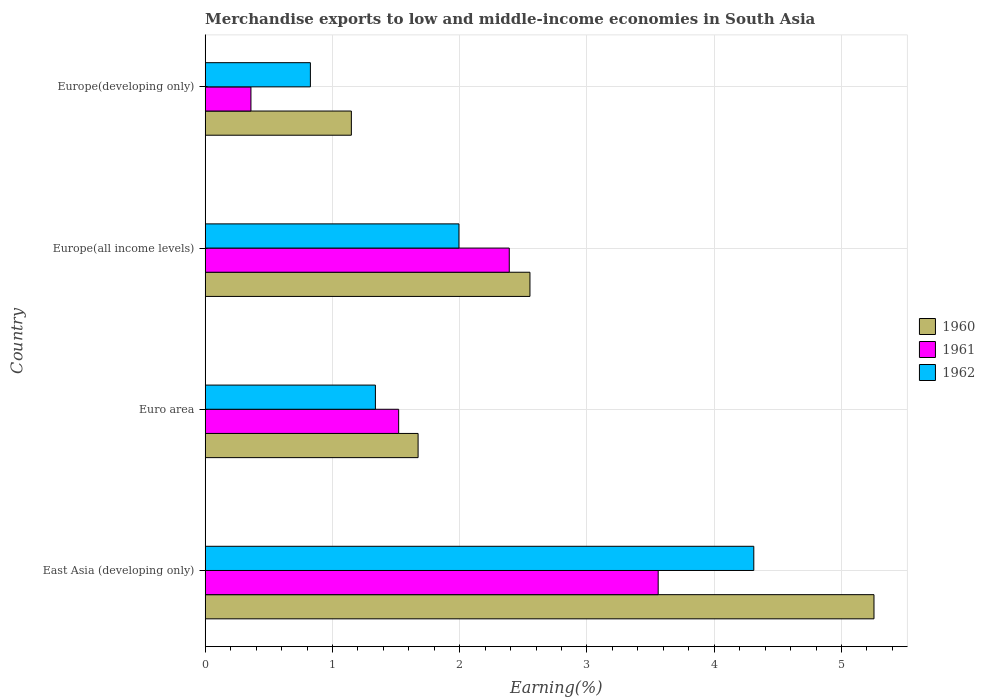How many different coloured bars are there?
Your answer should be compact. 3. How many groups of bars are there?
Your answer should be compact. 4. Are the number of bars on each tick of the Y-axis equal?
Provide a succinct answer. Yes. How many bars are there on the 2nd tick from the top?
Your answer should be very brief. 3. How many bars are there on the 2nd tick from the bottom?
Give a very brief answer. 3. What is the label of the 4th group of bars from the top?
Keep it short and to the point. East Asia (developing only). What is the percentage of amount earned from merchandise exports in 1961 in Europe(all income levels)?
Keep it short and to the point. 2.39. Across all countries, what is the maximum percentage of amount earned from merchandise exports in 1960?
Your response must be concise. 5.26. Across all countries, what is the minimum percentage of amount earned from merchandise exports in 1961?
Keep it short and to the point. 0.36. In which country was the percentage of amount earned from merchandise exports in 1961 maximum?
Offer a very short reply. East Asia (developing only). In which country was the percentage of amount earned from merchandise exports in 1962 minimum?
Your response must be concise. Europe(developing only). What is the total percentage of amount earned from merchandise exports in 1962 in the graph?
Offer a terse response. 8.47. What is the difference between the percentage of amount earned from merchandise exports in 1962 in East Asia (developing only) and that in Euro area?
Offer a terse response. 2.97. What is the difference between the percentage of amount earned from merchandise exports in 1960 in Europe(all income levels) and the percentage of amount earned from merchandise exports in 1961 in East Asia (developing only)?
Your answer should be very brief. -1.01. What is the average percentage of amount earned from merchandise exports in 1960 per country?
Your answer should be very brief. 2.66. What is the difference between the percentage of amount earned from merchandise exports in 1961 and percentage of amount earned from merchandise exports in 1960 in Euro area?
Offer a very short reply. -0.15. In how many countries, is the percentage of amount earned from merchandise exports in 1962 greater than 2.6 %?
Provide a short and direct response. 1. What is the ratio of the percentage of amount earned from merchandise exports in 1960 in East Asia (developing only) to that in Europe(developing only)?
Provide a short and direct response. 4.58. What is the difference between the highest and the second highest percentage of amount earned from merchandise exports in 1962?
Offer a terse response. 2.32. What is the difference between the highest and the lowest percentage of amount earned from merchandise exports in 1962?
Give a very brief answer. 3.48. In how many countries, is the percentage of amount earned from merchandise exports in 1962 greater than the average percentage of amount earned from merchandise exports in 1962 taken over all countries?
Offer a very short reply. 1. What does the 1st bar from the top in Euro area represents?
Your response must be concise. 1962. What does the 1st bar from the bottom in East Asia (developing only) represents?
Provide a succinct answer. 1960. Is it the case that in every country, the sum of the percentage of amount earned from merchandise exports in 1962 and percentage of amount earned from merchandise exports in 1961 is greater than the percentage of amount earned from merchandise exports in 1960?
Offer a very short reply. Yes. How many bars are there?
Provide a short and direct response. 12. Where does the legend appear in the graph?
Give a very brief answer. Center right. How many legend labels are there?
Provide a short and direct response. 3. What is the title of the graph?
Offer a very short reply. Merchandise exports to low and middle-income economies in South Asia. Does "1971" appear as one of the legend labels in the graph?
Make the answer very short. No. What is the label or title of the X-axis?
Ensure brevity in your answer.  Earning(%). What is the Earning(%) of 1960 in East Asia (developing only)?
Make the answer very short. 5.26. What is the Earning(%) of 1961 in East Asia (developing only)?
Ensure brevity in your answer.  3.56. What is the Earning(%) in 1962 in East Asia (developing only)?
Your response must be concise. 4.31. What is the Earning(%) in 1960 in Euro area?
Provide a short and direct response. 1.67. What is the Earning(%) in 1961 in Euro area?
Give a very brief answer. 1.52. What is the Earning(%) in 1962 in Euro area?
Your response must be concise. 1.34. What is the Earning(%) of 1960 in Europe(all income levels)?
Make the answer very short. 2.55. What is the Earning(%) in 1961 in Europe(all income levels)?
Your answer should be very brief. 2.39. What is the Earning(%) in 1962 in Europe(all income levels)?
Ensure brevity in your answer.  1.99. What is the Earning(%) of 1960 in Europe(developing only)?
Make the answer very short. 1.15. What is the Earning(%) of 1961 in Europe(developing only)?
Your response must be concise. 0.36. What is the Earning(%) in 1962 in Europe(developing only)?
Your answer should be compact. 0.83. Across all countries, what is the maximum Earning(%) of 1960?
Provide a short and direct response. 5.26. Across all countries, what is the maximum Earning(%) in 1961?
Provide a short and direct response. 3.56. Across all countries, what is the maximum Earning(%) in 1962?
Ensure brevity in your answer.  4.31. Across all countries, what is the minimum Earning(%) in 1960?
Your answer should be very brief. 1.15. Across all countries, what is the minimum Earning(%) of 1961?
Ensure brevity in your answer.  0.36. Across all countries, what is the minimum Earning(%) of 1962?
Provide a short and direct response. 0.83. What is the total Earning(%) of 1960 in the graph?
Offer a very short reply. 10.63. What is the total Earning(%) in 1961 in the graph?
Your response must be concise. 7.83. What is the total Earning(%) in 1962 in the graph?
Make the answer very short. 8.47. What is the difference between the Earning(%) of 1960 in East Asia (developing only) and that in Euro area?
Your answer should be compact. 3.58. What is the difference between the Earning(%) in 1961 in East Asia (developing only) and that in Euro area?
Provide a succinct answer. 2.04. What is the difference between the Earning(%) in 1962 in East Asia (developing only) and that in Euro area?
Your answer should be very brief. 2.97. What is the difference between the Earning(%) of 1960 in East Asia (developing only) and that in Europe(all income levels)?
Give a very brief answer. 2.7. What is the difference between the Earning(%) of 1961 in East Asia (developing only) and that in Europe(all income levels)?
Give a very brief answer. 1.17. What is the difference between the Earning(%) of 1962 in East Asia (developing only) and that in Europe(all income levels)?
Provide a short and direct response. 2.32. What is the difference between the Earning(%) of 1960 in East Asia (developing only) and that in Europe(developing only)?
Provide a succinct answer. 4.11. What is the difference between the Earning(%) in 1961 in East Asia (developing only) and that in Europe(developing only)?
Your response must be concise. 3.2. What is the difference between the Earning(%) in 1962 in East Asia (developing only) and that in Europe(developing only)?
Your response must be concise. 3.48. What is the difference between the Earning(%) of 1960 in Euro area and that in Europe(all income levels)?
Provide a succinct answer. -0.88. What is the difference between the Earning(%) of 1961 in Euro area and that in Europe(all income levels)?
Provide a succinct answer. -0.87. What is the difference between the Earning(%) of 1962 in Euro area and that in Europe(all income levels)?
Provide a short and direct response. -0.66. What is the difference between the Earning(%) in 1960 in Euro area and that in Europe(developing only)?
Your answer should be very brief. 0.52. What is the difference between the Earning(%) in 1961 in Euro area and that in Europe(developing only)?
Your response must be concise. 1.16. What is the difference between the Earning(%) in 1962 in Euro area and that in Europe(developing only)?
Offer a terse response. 0.51. What is the difference between the Earning(%) in 1960 in Europe(all income levels) and that in Europe(developing only)?
Ensure brevity in your answer.  1.4. What is the difference between the Earning(%) in 1961 in Europe(all income levels) and that in Europe(developing only)?
Provide a short and direct response. 2.03. What is the difference between the Earning(%) in 1962 in Europe(all income levels) and that in Europe(developing only)?
Your response must be concise. 1.17. What is the difference between the Earning(%) of 1960 in East Asia (developing only) and the Earning(%) of 1961 in Euro area?
Your response must be concise. 3.74. What is the difference between the Earning(%) in 1960 in East Asia (developing only) and the Earning(%) in 1962 in Euro area?
Give a very brief answer. 3.92. What is the difference between the Earning(%) in 1961 in East Asia (developing only) and the Earning(%) in 1962 in Euro area?
Your response must be concise. 2.22. What is the difference between the Earning(%) of 1960 in East Asia (developing only) and the Earning(%) of 1961 in Europe(all income levels)?
Make the answer very short. 2.87. What is the difference between the Earning(%) of 1960 in East Asia (developing only) and the Earning(%) of 1962 in Europe(all income levels)?
Give a very brief answer. 3.26. What is the difference between the Earning(%) in 1961 in East Asia (developing only) and the Earning(%) in 1962 in Europe(all income levels)?
Provide a short and direct response. 1.57. What is the difference between the Earning(%) of 1960 in East Asia (developing only) and the Earning(%) of 1961 in Europe(developing only)?
Your response must be concise. 4.9. What is the difference between the Earning(%) of 1960 in East Asia (developing only) and the Earning(%) of 1962 in Europe(developing only)?
Keep it short and to the point. 4.43. What is the difference between the Earning(%) of 1961 in East Asia (developing only) and the Earning(%) of 1962 in Europe(developing only)?
Give a very brief answer. 2.73. What is the difference between the Earning(%) of 1960 in Euro area and the Earning(%) of 1961 in Europe(all income levels)?
Offer a terse response. -0.72. What is the difference between the Earning(%) of 1960 in Euro area and the Earning(%) of 1962 in Europe(all income levels)?
Offer a terse response. -0.32. What is the difference between the Earning(%) in 1961 in Euro area and the Earning(%) in 1962 in Europe(all income levels)?
Give a very brief answer. -0.47. What is the difference between the Earning(%) of 1960 in Euro area and the Earning(%) of 1961 in Europe(developing only)?
Ensure brevity in your answer.  1.31. What is the difference between the Earning(%) of 1960 in Euro area and the Earning(%) of 1962 in Europe(developing only)?
Ensure brevity in your answer.  0.85. What is the difference between the Earning(%) in 1961 in Euro area and the Earning(%) in 1962 in Europe(developing only)?
Provide a short and direct response. 0.69. What is the difference between the Earning(%) in 1960 in Europe(all income levels) and the Earning(%) in 1961 in Europe(developing only)?
Provide a short and direct response. 2.19. What is the difference between the Earning(%) of 1960 in Europe(all income levels) and the Earning(%) of 1962 in Europe(developing only)?
Your response must be concise. 1.73. What is the difference between the Earning(%) in 1961 in Europe(all income levels) and the Earning(%) in 1962 in Europe(developing only)?
Provide a short and direct response. 1.56. What is the average Earning(%) in 1960 per country?
Provide a succinct answer. 2.66. What is the average Earning(%) in 1961 per country?
Keep it short and to the point. 1.96. What is the average Earning(%) of 1962 per country?
Ensure brevity in your answer.  2.12. What is the difference between the Earning(%) of 1960 and Earning(%) of 1961 in East Asia (developing only)?
Your answer should be very brief. 1.7. What is the difference between the Earning(%) in 1960 and Earning(%) in 1962 in East Asia (developing only)?
Offer a very short reply. 0.94. What is the difference between the Earning(%) in 1961 and Earning(%) in 1962 in East Asia (developing only)?
Offer a terse response. -0.75. What is the difference between the Earning(%) in 1960 and Earning(%) in 1961 in Euro area?
Offer a terse response. 0.15. What is the difference between the Earning(%) in 1960 and Earning(%) in 1962 in Euro area?
Your response must be concise. 0.34. What is the difference between the Earning(%) in 1961 and Earning(%) in 1962 in Euro area?
Provide a succinct answer. 0.18. What is the difference between the Earning(%) in 1960 and Earning(%) in 1961 in Europe(all income levels)?
Give a very brief answer. 0.16. What is the difference between the Earning(%) in 1960 and Earning(%) in 1962 in Europe(all income levels)?
Your answer should be very brief. 0.56. What is the difference between the Earning(%) in 1961 and Earning(%) in 1962 in Europe(all income levels)?
Your answer should be very brief. 0.4. What is the difference between the Earning(%) in 1960 and Earning(%) in 1961 in Europe(developing only)?
Provide a short and direct response. 0.79. What is the difference between the Earning(%) of 1960 and Earning(%) of 1962 in Europe(developing only)?
Offer a terse response. 0.32. What is the difference between the Earning(%) in 1961 and Earning(%) in 1962 in Europe(developing only)?
Offer a terse response. -0.47. What is the ratio of the Earning(%) of 1960 in East Asia (developing only) to that in Euro area?
Keep it short and to the point. 3.14. What is the ratio of the Earning(%) in 1961 in East Asia (developing only) to that in Euro area?
Keep it short and to the point. 2.34. What is the ratio of the Earning(%) of 1962 in East Asia (developing only) to that in Euro area?
Provide a succinct answer. 3.22. What is the ratio of the Earning(%) in 1960 in East Asia (developing only) to that in Europe(all income levels)?
Your answer should be very brief. 2.06. What is the ratio of the Earning(%) in 1961 in East Asia (developing only) to that in Europe(all income levels)?
Offer a very short reply. 1.49. What is the ratio of the Earning(%) of 1962 in East Asia (developing only) to that in Europe(all income levels)?
Offer a terse response. 2.16. What is the ratio of the Earning(%) of 1960 in East Asia (developing only) to that in Europe(developing only)?
Provide a short and direct response. 4.58. What is the ratio of the Earning(%) of 1961 in East Asia (developing only) to that in Europe(developing only)?
Provide a succinct answer. 9.9. What is the ratio of the Earning(%) in 1962 in East Asia (developing only) to that in Europe(developing only)?
Provide a short and direct response. 5.22. What is the ratio of the Earning(%) in 1960 in Euro area to that in Europe(all income levels)?
Make the answer very short. 0.66. What is the ratio of the Earning(%) in 1961 in Euro area to that in Europe(all income levels)?
Give a very brief answer. 0.64. What is the ratio of the Earning(%) of 1962 in Euro area to that in Europe(all income levels)?
Offer a very short reply. 0.67. What is the ratio of the Earning(%) of 1960 in Euro area to that in Europe(developing only)?
Provide a succinct answer. 1.46. What is the ratio of the Earning(%) in 1961 in Euro area to that in Europe(developing only)?
Make the answer very short. 4.23. What is the ratio of the Earning(%) of 1962 in Euro area to that in Europe(developing only)?
Your answer should be very brief. 1.62. What is the ratio of the Earning(%) in 1960 in Europe(all income levels) to that in Europe(developing only)?
Provide a short and direct response. 2.22. What is the ratio of the Earning(%) in 1961 in Europe(all income levels) to that in Europe(developing only)?
Offer a terse response. 6.65. What is the ratio of the Earning(%) of 1962 in Europe(all income levels) to that in Europe(developing only)?
Give a very brief answer. 2.41. What is the difference between the highest and the second highest Earning(%) in 1960?
Ensure brevity in your answer.  2.7. What is the difference between the highest and the second highest Earning(%) in 1961?
Provide a short and direct response. 1.17. What is the difference between the highest and the second highest Earning(%) in 1962?
Keep it short and to the point. 2.32. What is the difference between the highest and the lowest Earning(%) in 1960?
Your answer should be very brief. 4.11. What is the difference between the highest and the lowest Earning(%) of 1961?
Give a very brief answer. 3.2. What is the difference between the highest and the lowest Earning(%) in 1962?
Provide a short and direct response. 3.48. 